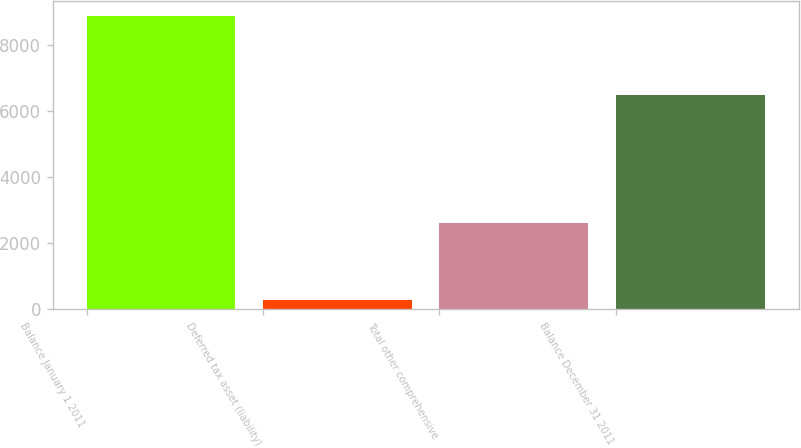<chart> <loc_0><loc_0><loc_500><loc_500><bar_chart><fcel>Balance January 1 2011<fcel>Deferred tax asset (liability)<fcel>Total other comprehensive<fcel>Balance December 31 2011<nl><fcel>8871<fcel>262<fcel>2604<fcel>6481<nl></chart> 